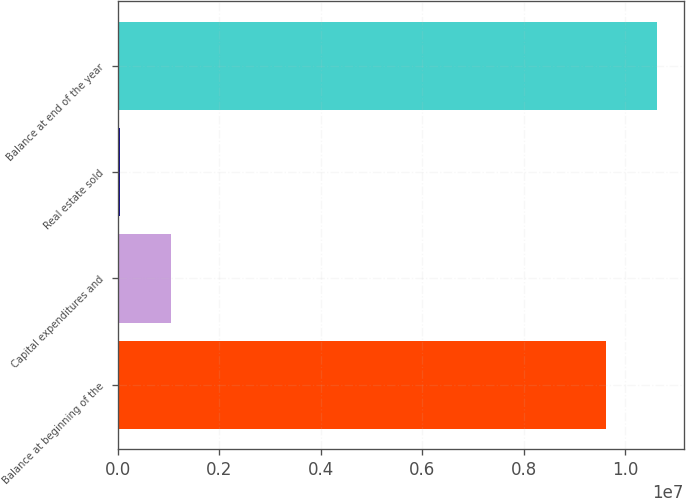Convert chart to OTSL. <chart><loc_0><loc_0><loc_500><loc_500><bar_chart><fcel>Balance at beginning of the<fcel>Capital expenditures and<fcel>Real estate sold<fcel>Balance at end of the year<nl><fcel>9.61575e+06<fcel>1.05693e+06<fcel>43569<fcel>1.06291e+07<nl></chart> 